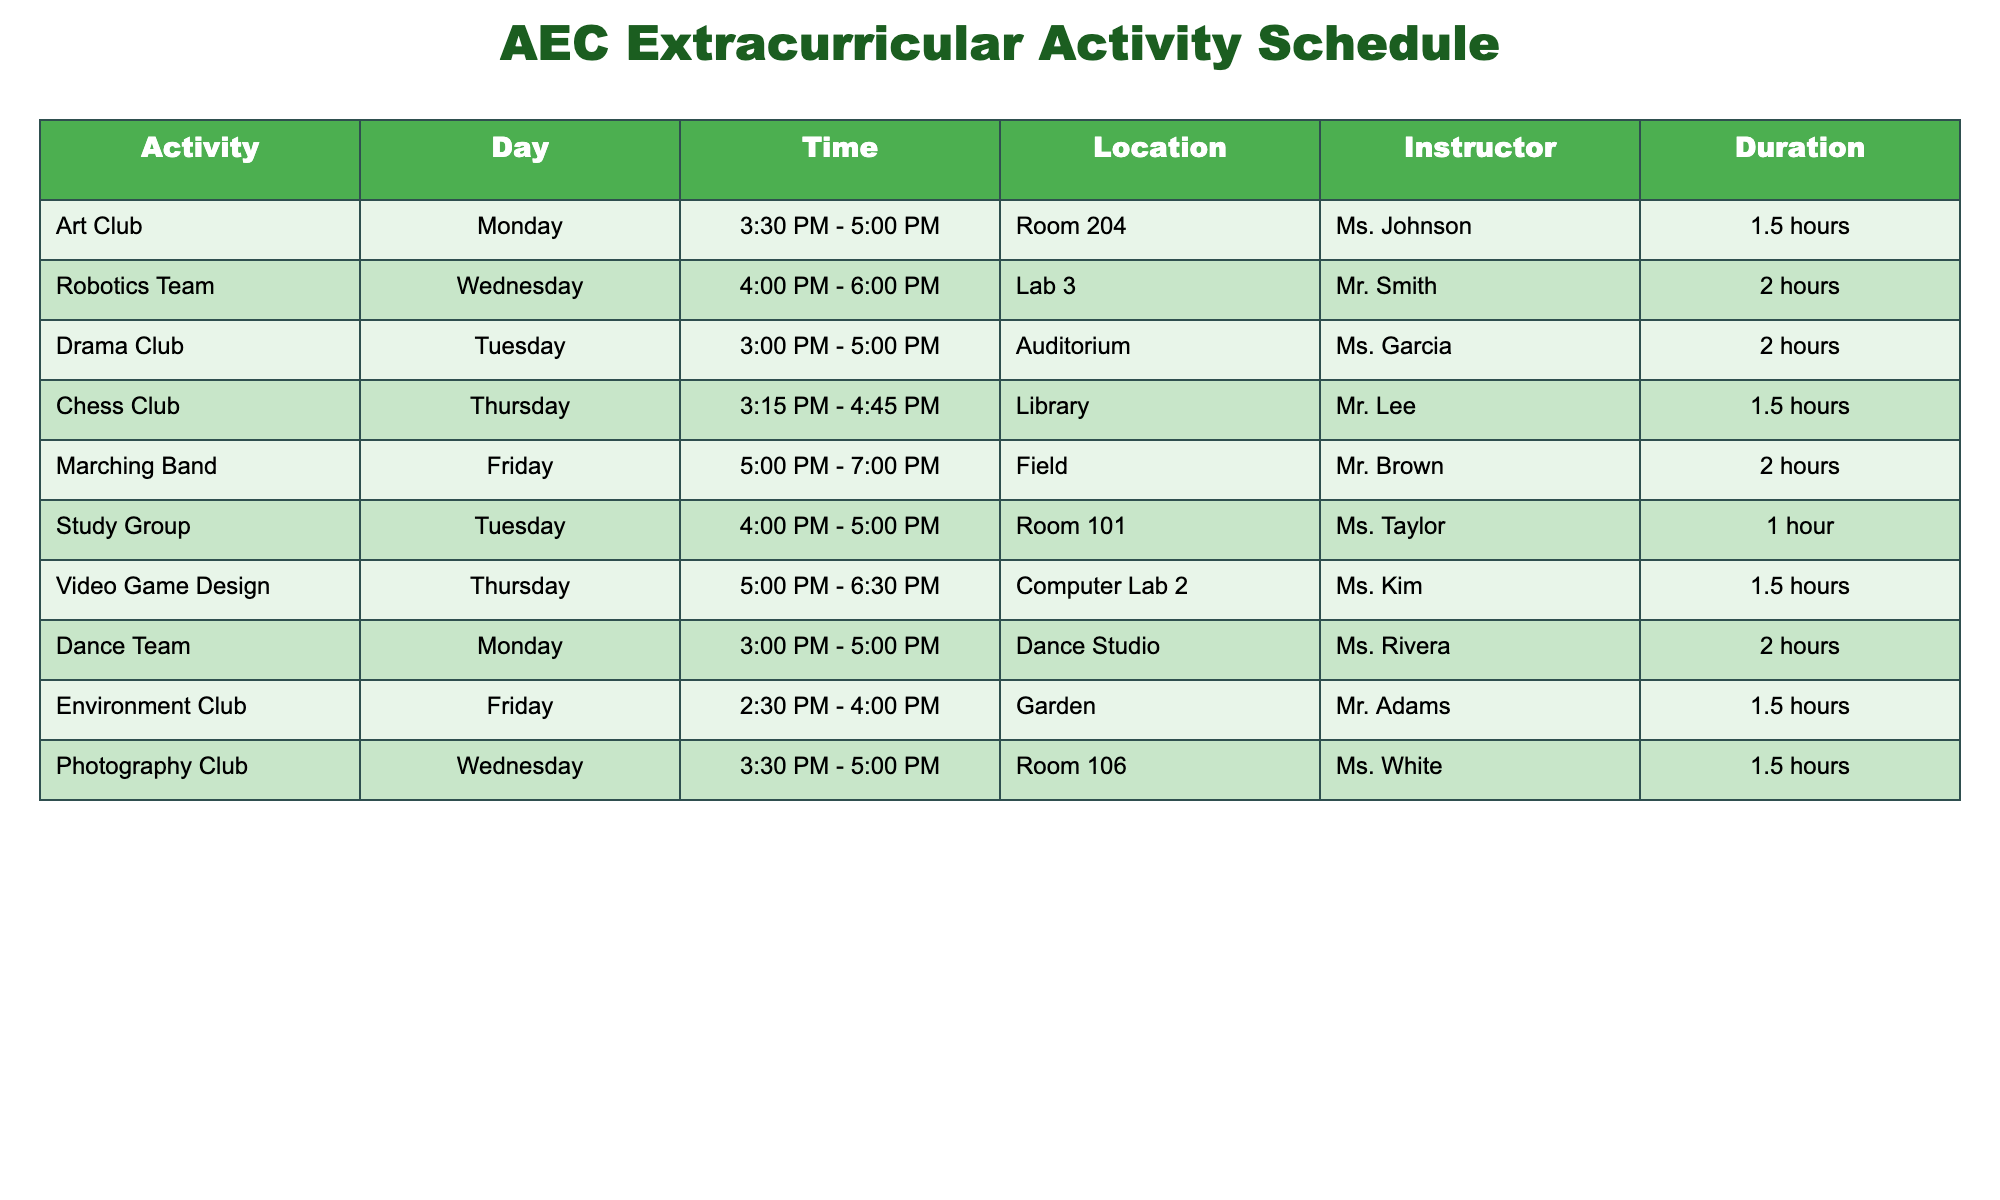What day does the Robotics Team meet? The table clearly states that Robotics Team meets on Wednesday.
Answer: Wednesday How long is the Marching Band practice? According to the table, Marching Band has a duration of 2 hours.
Answer: 2 hours On which day can my child participate in the Environment Club? The table indicates that the Environment Club meets on Friday.
Answer: Friday Is the Dance Team meeting on Tuesday? According to the table, the Dance Team meets on Monday, not Tuesday.
Answer: No What is the total duration of the study sessions for the Study Group and Video Game Design? The Study Group lasts for 1 hour, and Video Game Design lasts for 1.5 hours. Adding these together gives 1 + 1.5 = 2.5 hours.
Answer: 2.5 hours Which activity has the latest start time, and what is that time? By reviewing the start times of all activities, the Robotics Team starts at 4:00 PM, which is the latest among the activities listed.
Answer: 4:00 PM Does the Chess Club meet before 4 PM? Checking the meeting time for the Chess Club, which is from 3:15 PM to 4:45 PM, confirms that it starts at 3:15 PM, which is before 4 PM.
Answer: Yes What is the average duration of the clubs and teams listed this week? The durations are 1.5, 2, 2, 1.5, 2, 1, 1.5, 2, 1.5 hours. Summing these gives 12 hours, and since there are 9 activities, the average is 12 / 9 = 1.33 hours.
Answer: 1.33 hours Which instructor is responsible for the Art Club? By looking at the table, it shows that the instructor for the Art Club is Ms. Johnson.
Answer: Ms. Johnson 